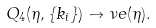<formula> <loc_0><loc_0><loc_500><loc_500>Q _ { 4 } ( \eta , \{ k _ { i } \} ) \to \nu e ( \eta ) .</formula> 